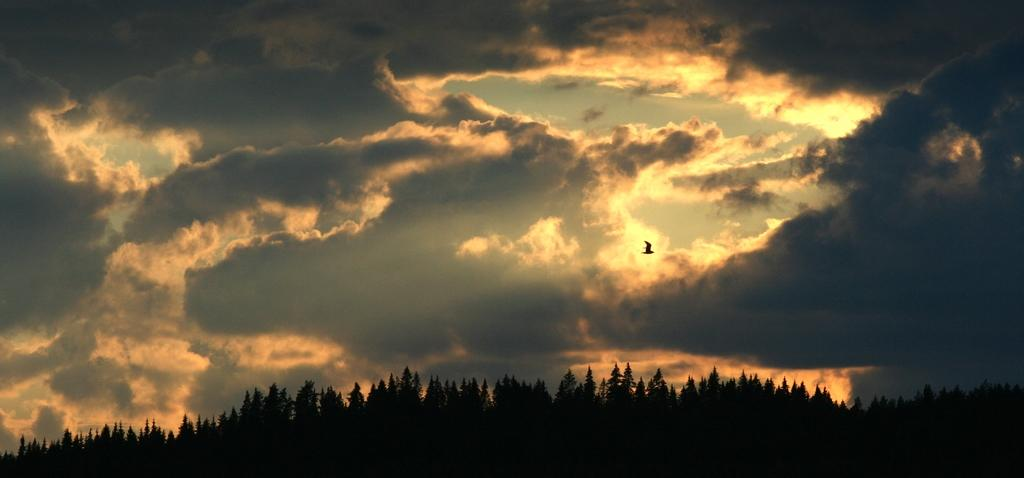What is the weather like in the image? The sky in the image is cloudy, indicating a potentially overcast or cloudy day. What can be seen flying in the image? There is a bird flying in the image. What type of vegetation is visible at the bottom of the image? There are many trees visible at the bottom of the image. How many babies are playing volleyball in the image? There are no babies or volleyball present in the image. Who is the partner of the bird flying in the image? The bird is not shown with a partner in the image, as it is flying alone. 